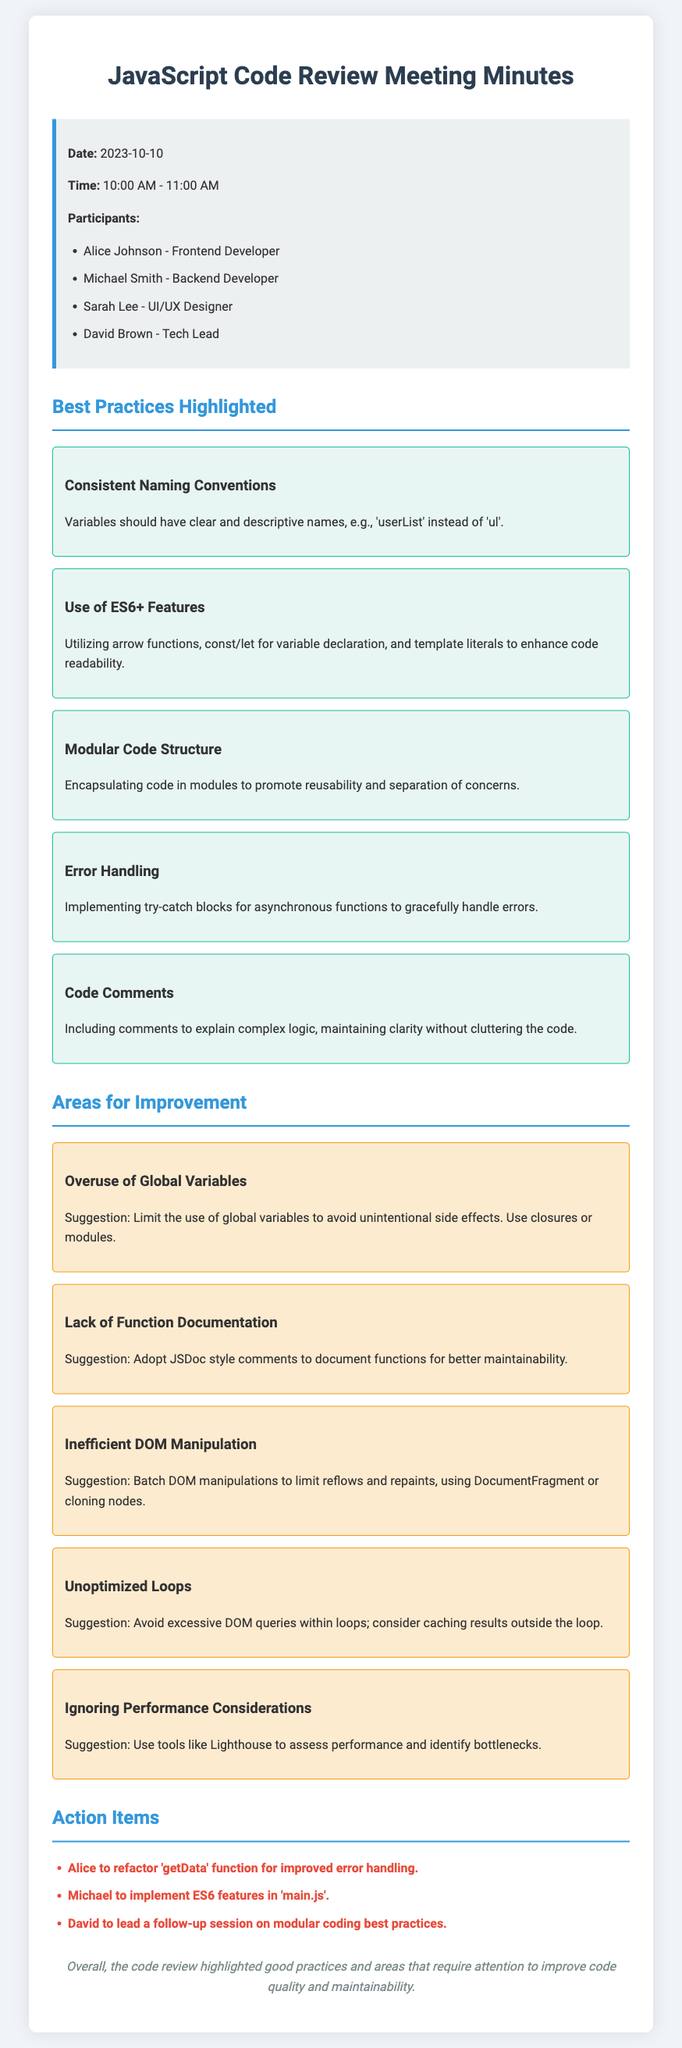What was the date of the meeting? The date is mentioned at the beginning of the document within the info box.
Answer: 2023-10-10 Who are the participants listed in the meeting? The participants are specifically listed in the info box of the document.
Answer: Alice Johnson, Michael Smith, Sarah Lee, David Brown What is one of the best practices highlighted in the meeting? The best practices are listed in highlight boxes under the relevant section in the document.
Answer: Consistent Naming Conventions What suggestion was made regarding global variables? The suggestion relates to the area for improvement regarding the issue of global variables in the document.
Answer: Limit the use of global variables to avoid unintentional side effects How many action items are there? The action items are listed in a bullet section towards the end of the document.
Answer: Three What is the background color of the info box? The background color is described in the style section of the document, but it's also visually identifiable in the rendered document.
Answer: Light gray Who is responsible for leading a follow-up session? The responsibility is specified in the action items section in the document.
Answer: David What is the purpose of implementing try-catch blocks? The purpose is explained in the best practices section regarding error handling.
Answer: Gracefully handle errors 